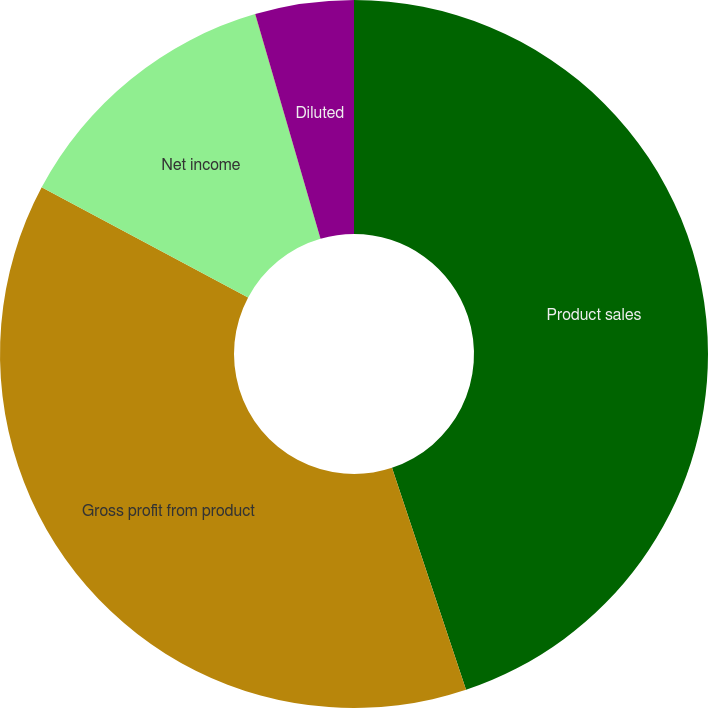<chart> <loc_0><loc_0><loc_500><loc_500><pie_chart><fcel>Product sales<fcel>Gross profit from product<fcel>Net income<fcel>Basic<fcel>Diluted<nl><fcel>44.88%<fcel>37.93%<fcel>12.69%<fcel>0.01%<fcel>4.5%<nl></chart> 